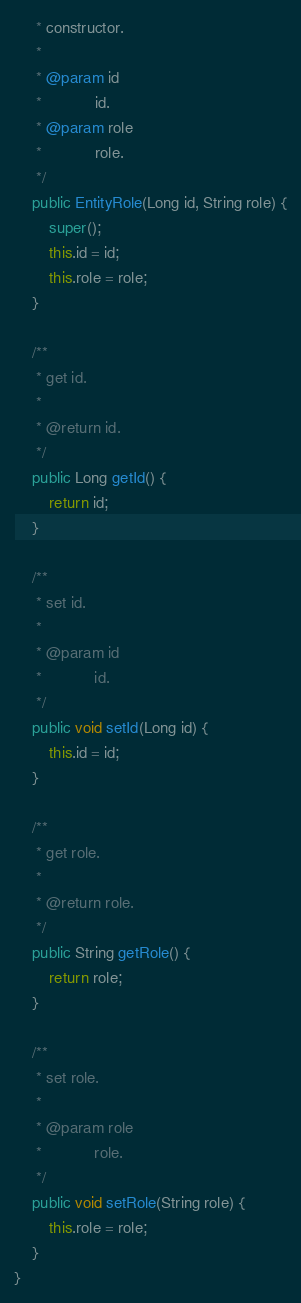Convert code to text. <code><loc_0><loc_0><loc_500><loc_500><_Java_>     * constructor.
     * 
     * @param id
     *            id.
     * @param role
     *            role.
     */
    public EntityRole(Long id, String role) {
        super();
        this.id = id;
        this.role = role;
    }

    /**
     * get id.
     * 
     * @return id.
     */
    public Long getId() {
        return id;
    }

    /**
     * set id.
     * 
     * @param id
     *            id.
     */
    public void setId(Long id) {
        this.id = id;
    }

    /**
     * get role.
     * 
     * @return role.
     */
    public String getRole() {
        return role;
    }

    /**
     * set role.
     * 
     * @param role
     *            role.
     */
    public void setRole(String role) {
        this.role = role;
    }
}
</code> 